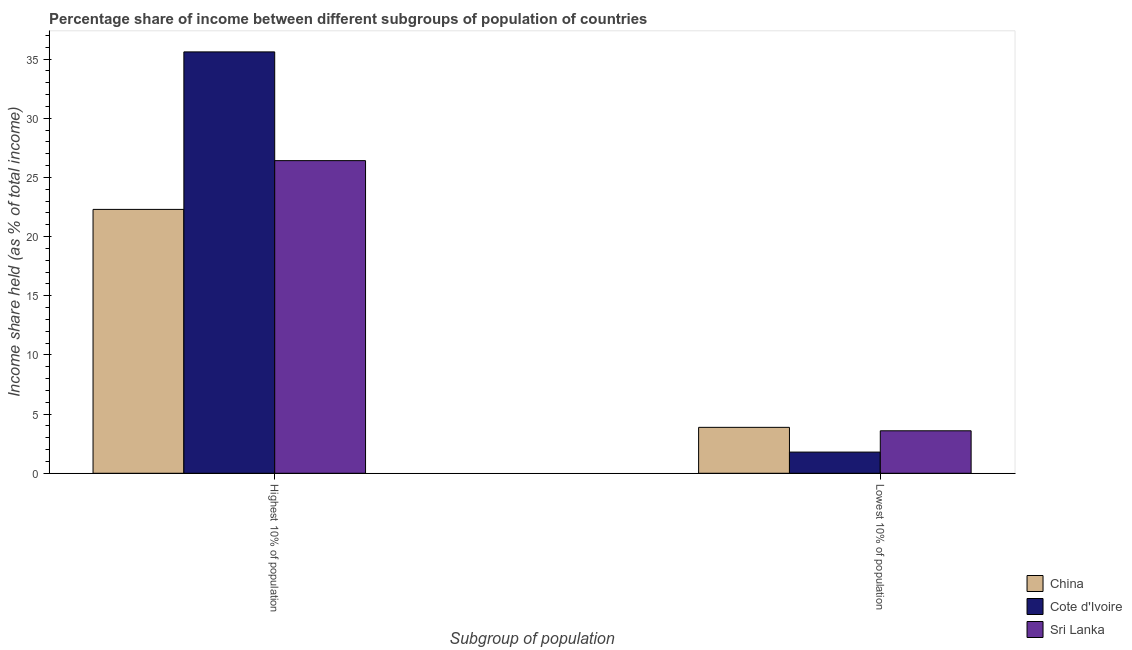Are the number of bars per tick equal to the number of legend labels?
Provide a short and direct response. Yes. Are the number of bars on each tick of the X-axis equal?
Offer a terse response. Yes. How many bars are there on the 1st tick from the right?
Ensure brevity in your answer.  3. What is the label of the 2nd group of bars from the left?
Your response must be concise. Lowest 10% of population. What is the income share held by lowest 10% of the population in Sri Lanka?
Make the answer very short. 3.59. Across all countries, what is the maximum income share held by highest 10% of the population?
Offer a terse response. 35.61. Across all countries, what is the minimum income share held by highest 10% of the population?
Offer a terse response. 22.3. In which country was the income share held by highest 10% of the population maximum?
Your answer should be very brief. Cote d'Ivoire. In which country was the income share held by highest 10% of the population minimum?
Make the answer very short. China. What is the total income share held by highest 10% of the population in the graph?
Make the answer very short. 84.33. What is the difference between the income share held by lowest 10% of the population in Sri Lanka and that in China?
Make the answer very short. -0.29. What is the difference between the income share held by highest 10% of the population in China and the income share held by lowest 10% of the population in Cote d'Ivoire?
Your answer should be very brief. 20.51. What is the average income share held by highest 10% of the population per country?
Keep it short and to the point. 28.11. What is the difference between the income share held by lowest 10% of the population and income share held by highest 10% of the population in Sri Lanka?
Give a very brief answer. -22.83. In how many countries, is the income share held by highest 10% of the population greater than 1 %?
Your answer should be very brief. 3. What is the ratio of the income share held by highest 10% of the population in Cote d'Ivoire to that in Sri Lanka?
Your response must be concise. 1.35. Is the income share held by highest 10% of the population in China less than that in Cote d'Ivoire?
Your answer should be very brief. Yes. What does the 3rd bar from the left in Highest 10% of population represents?
Keep it short and to the point. Sri Lanka. What does the 3rd bar from the right in Lowest 10% of population represents?
Your answer should be compact. China. What is the difference between two consecutive major ticks on the Y-axis?
Your answer should be compact. 5. Are the values on the major ticks of Y-axis written in scientific E-notation?
Make the answer very short. No. Does the graph contain grids?
Your answer should be compact. No. Where does the legend appear in the graph?
Keep it short and to the point. Bottom right. How many legend labels are there?
Your response must be concise. 3. What is the title of the graph?
Keep it short and to the point. Percentage share of income between different subgroups of population of countries. Does "St. Kitts and Nevis" appear as one of the legend labels in the graph?
Your answer should be very brief. No. What is the label or title of the X-axis?
Provide a succinct answer. Subgroup of population. What is the label or title of the Y-axis?
Make the answer very short. Income share held (as % of total income). What is the Income share held (as % of total income) of China in Highest 10% of population?
Provide a succinct answer. 22.3. What is the Income share held (as % of total income) of Cote d'Ivoire in Highest 10% of population?
Give a very brief answer. 35.61. What is the Income share held (as % of total income) of Sri Lanka in Highest 10% of population?
Offer a terse response. 26.42. What is the Income share held (as % of total income) in China in Lowest 10% of population?
Your response must be concise. 3.88. What is the Income share held (as % of total income) of Cote d'Ivoire in Lowest 10% of population?
Your answer should be compact. 1.79. What is the Income share held (as % of total income) in Sri Lanka in Lowest 10% of population?
Give a very brief answer. 3.59. Across all Subgroup of population, what is the maximum Income share held (as % of total income) in China?
Make the answer very short. 22.3. Across all Subgroup of population, what is the maximum Income share held (as % of total income) in Cote d'Ivoire?
Your answer should be compact. 35.61. Across all Subgroup of population, what is the maximum Income share held (as % of total income) of Sri Lanka?
Your answer should be compact. 26.42. Across all Subgroup of population, what is the minimum Income share held (as % of total income) of China?
Provide a short and direct response. 3.88. Across all Subgroup of population, what is the minimum Income share held (as % of total income) in Cote d'Ivoire?
Your response must be concise. 1.79. Across all Subgroup of population, what is the minimum Income share held (as % of total income) of Sri Lanka?
Offer a terse response. 3.59. What is the total Income share held (as % of total income) in China in the graph?
Your response must be concise. 26.18. What is the total Income share held (as % of total income) in Cote d'Ivoire in the graph?
Offer a very short reply. 37.4. What is the total Income share held (as % of total income) of Sri Lanka in the graph?
Provide a succinct answer. 30.01. What is the difference between the Income share held (as % of total income) of China in Highest 10% of population and that in Lowest 10% of population?
Provide a succinct answer. 18.42. What is the difference between the Income share held (as % of total income) in Cote d'Ivoire in Highest 10% of population and that in Lowest 10% of population?
Provide a succinct answer. 33.82. What is the difference between the Income share held (as % of total income) of Sri Lanka in Highest 10% of population and that in Lowest 10% of population?
Your response must be concise. 22.83. What is the difference between the Income share held (as % of total income) in China in Highest 10% of population and the Income share held (as % of total income) in Cote d'Ivoire in Lowest 10% of population?
Your response must be concise. 20.51. What is the difference between the Income share held (as % of total income) in China in Highest 10% of population and the Income share held (as % of total income) in Sri Lanka in Lowest 10% of population?
Ensure brevity in your answer.  18.71. What is the difference between the Income share held (as % of total income) of Cote d'Ivoire in Highest 10% of population and the Income share held (as % of total income) of Sri Lanka in Lowest 10% of population?
Ensure brevity in your answer.  32.02. What is the average Income share held (as % of total income) of China per Subgroup of population?
Your answer should be compact. 13.09. What is the average Income share held (as % of total income) in Cote d'Ivoire per Subgroup of population?
Ensure brevity in your answer.  18.7. What is the average Income share held (as % of total income) in Sri Lanka per Subgroup of population?
Your answer should be very brief. 15.01. What is the difference between the Income share held (as % of total income) in China and Income share held (as % of total income) in Cote d'Ivoire in Highest 10% of population?
Provide a succinct answer. -13.31. What is the difference between the Income share held (as % of total income) in China and Income share held (as % of total income) in Sri Lanka in Highest 10% of population?
Provide a succinct answer. -4.12. What is the difference between the Income share held (as % of total income) in Cote d'Ivoire and Income share held (as % of total income) in Sri Lanka in Highest 10% of population?
Ensure brevity in your answer.  9.19. What is the difference between the Income share held (as % of total income) in China and Income share held (as % of total income) in Cote d'Ivoire in Lowest 10% of population?
Give a very brief answer. 2.09. What is the difference between the Income share held (as % of total income) in China and Income share held (as % of total income) in Sri Lanka in Lowest 10% of population?
Your answer should be compact. 0.29. What is the ratio of the Income share held (as % of total income) of China in Highest 10% of population to that in Lowest 10% of population?
Keep it short and to the point. 5.75. What is the ratio of the Income share held (as % of total income) of Cote d'Ivoire in Highest 10% of population to that in Lowest 10% of population?
Offer a terse response. 19.89. What is the ratio of the Income share held (as % of total income) in Sri Lanka in Highest 10% of population to that in Lowest 10% of population?
Give a very brief answer. 7.36. What is the difference between the highest and the second highest Income share held (as % of total income) in China?
Make the answer very short. 18.42. What is the difference between the highest and the second highest Income share held (as % of total income) of Cote d'Ivoire?
Offer a very short reply. 33.82. What is the difference between the highest and the second highest Income share held (as % of total income) in Sri Lanka?
Offer a very short reply. 22.83. What is the difference between the highest and the lowest Income share held (as % of total income) in China?
Your response must be concise. 18.42. What is the difference between the highest and the lowest Income share held (as % of total income) of Cote d'Ivoire?
Make the answer very short. 33.82. What is the difference between the highest and the lowest Income share held (as % of total income) of Sri Lanka?
Offer a terse response. 22.83. 